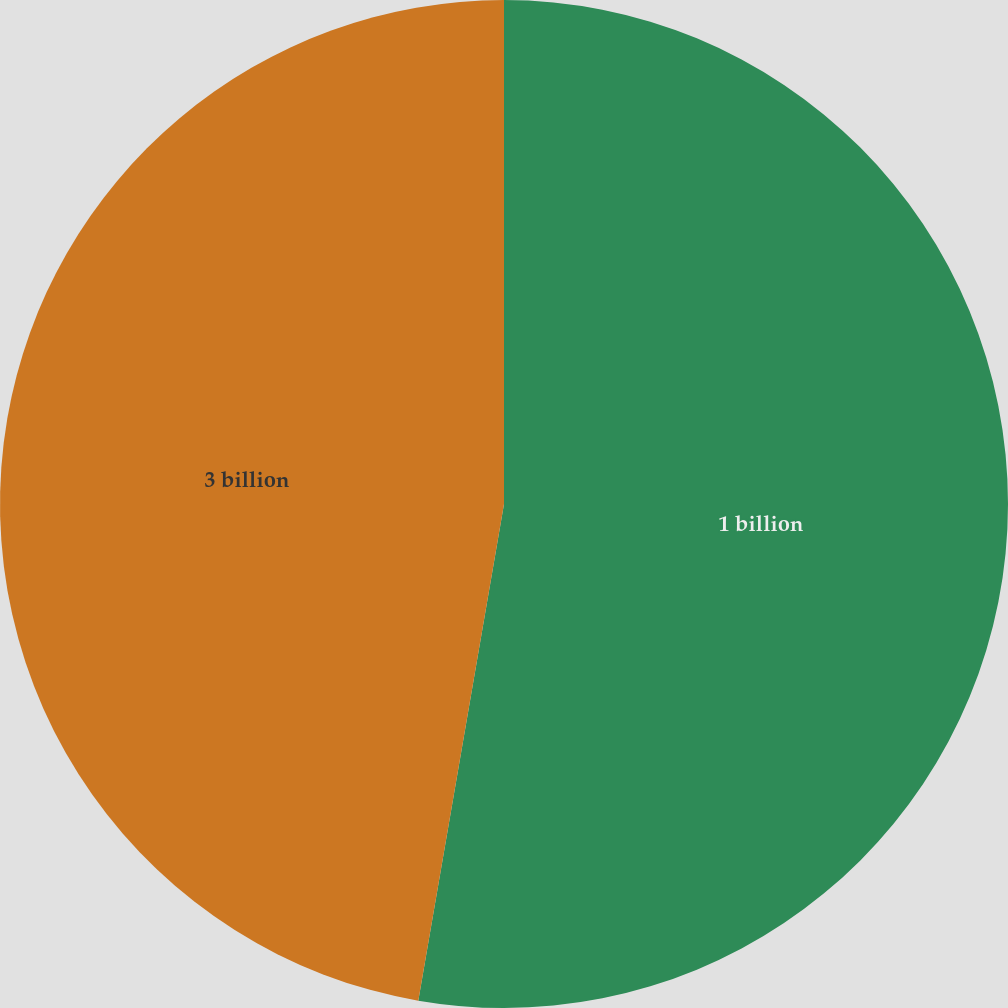Convert chart. <chart><loc_0><loc_0><loc_500><loc_500><pie_chart><fcel>1 billion<fcel>3 billion<nl><fcel>52.72%<fcel>47.28%<nl></chart> 